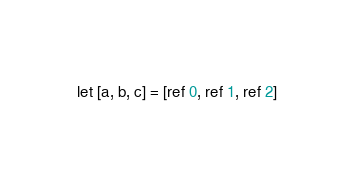Convert code to text. <code><loc_0><loc_0><loc_500><loc_500><_OCaml_>let [a, b, c] = [ref 0, ref 1, ref 2]
</code> 